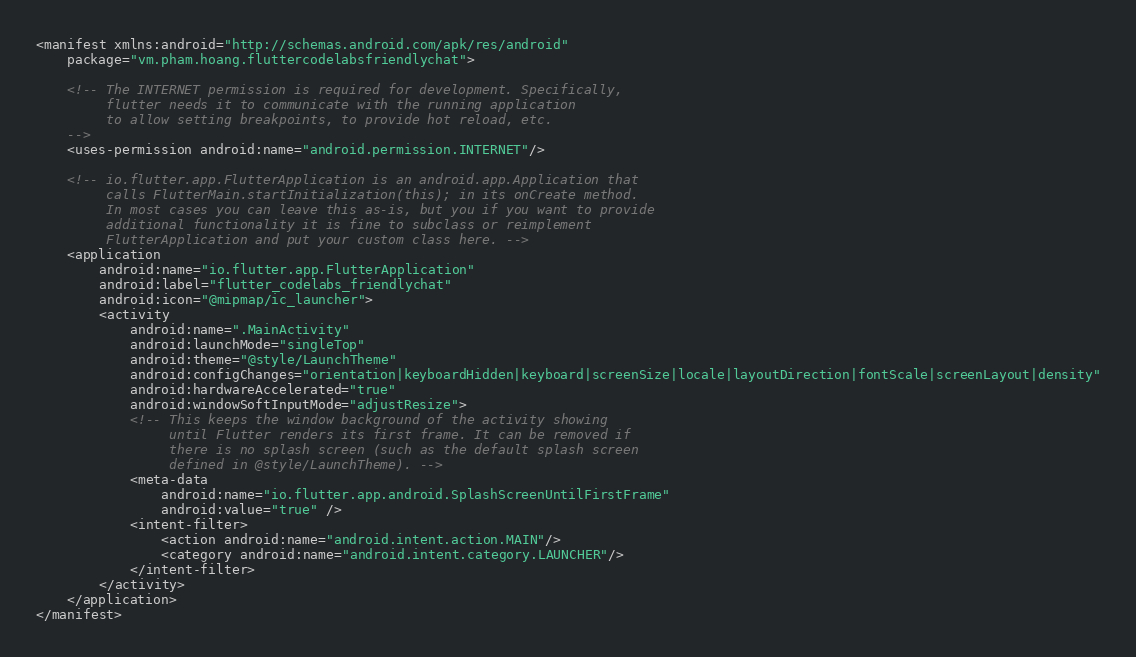<code> <loc_0><loc_0><loc_500><loc_500><_XML_><manifest xmlns:android="http://schemas.android.com/apk/res/android"
    package="vm.pham.hoang.fluttercodelabsfriendlychat">

    <!-- The INTERNET permission is required for development. Specifically,
         flutter needs it to communicate with the running application
         to allow setting breakpoints, to provide hot reload, etc.
    -->
    <uses-permission android:name="android.permission.INTERNET"/>

    <!-- io.flutter.app.FlutterApplication is an android.app.Application that
         calls FlutterMain.startInitialization(this); in its onCreate method.
         In most cases you can leave this as-is, but you if you want to provide
         additional functionality it is fine to subclass or reimplement
         FlutterApplication and put your custom class here. -->
    <application
        android:name="io.flutter.app.FlutterApplication"
        android:label="flutter_codelabs_friendlychat"
        android:icon="@mipmap/ic_launcher">
        <activity
            android:name=".MainActivity"
            android:launchMode="singleTop"
            android:theme="@style/LaunchTheme"
            android:configChanges="orientation|keyboardHidden|keyboard|screenSize|locale|layoutDirection|fontScale|screenLayout|density"
            android:hardwareAccelerated="true"
            android:windowSoftInputMode="adjustResize">
            <!-- This keeps the window background of the activity showing
                 until Flutter renders its first frame. It can be removed if
                 there is no splash screen (such as the default splash screen
                 defined in @style/LaunchTheme). -->
            <meta-data
                android:name="io.flutter.app.android.SplashScreenUntilFirstFrame"
                android:value="true" />
            <intent-filter>
                <action android:name="android.intent.action.MAIN"/>
                <category android:name="android.intent.category.LAUNCHER"/>
            </intent-filter>
        </activity>
    </application>
</manifest>
</code> 